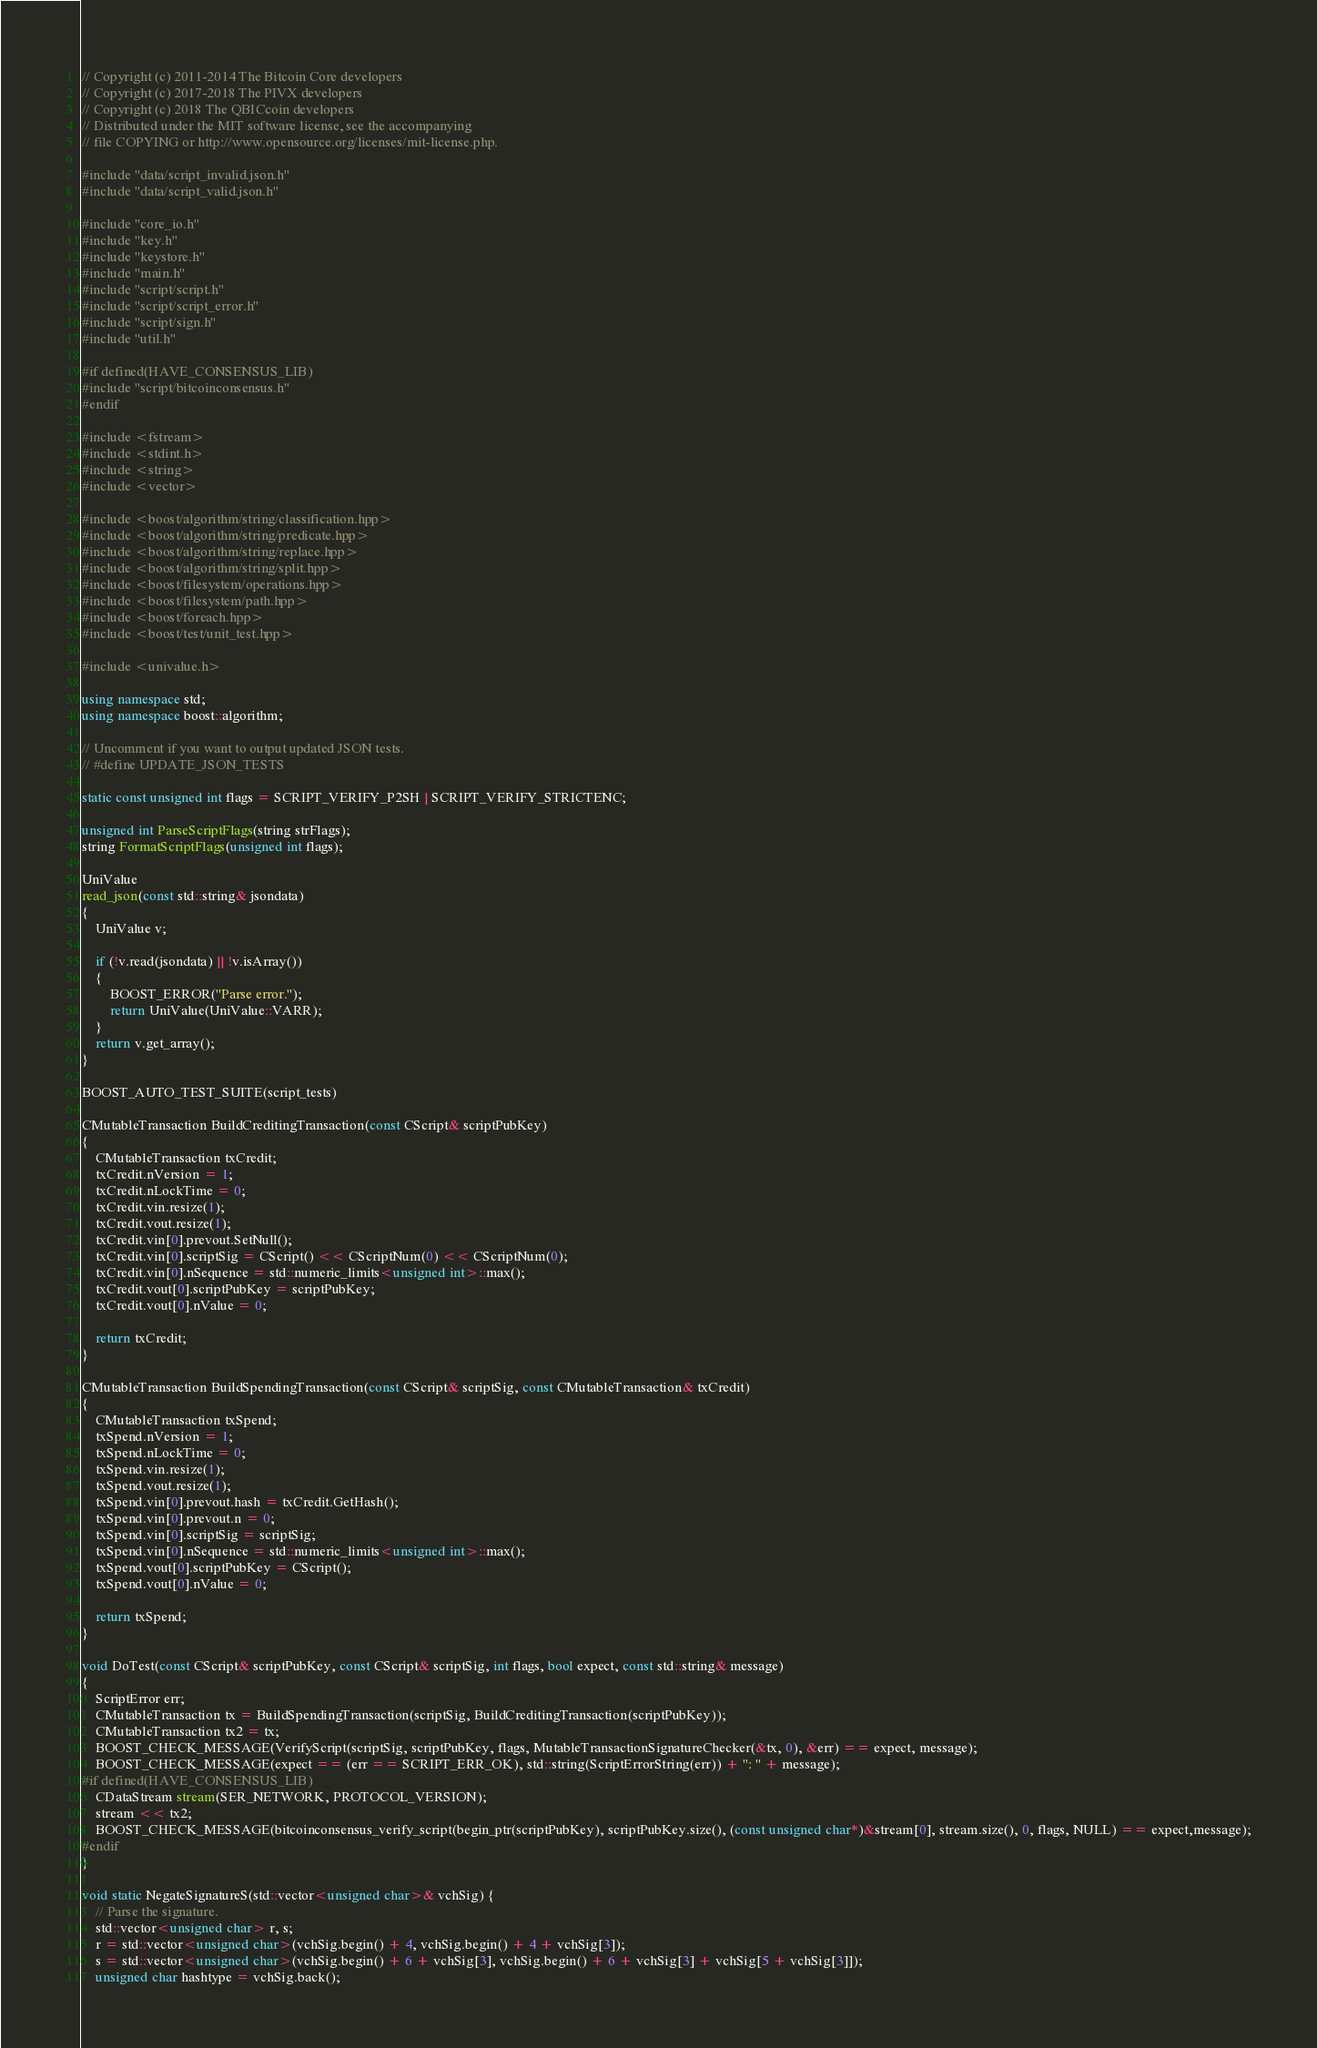Convert code to text. <code><loc_0><loc_0><loc_500><loc_500><_C++_>// Copyright (c) 2011-2014 The Bitcoin Core developers
// Copyright (c) 2017-2018 The PIVX developers
// Copyright (c) 2018 The QBICcoin developers
// Distributed under the MIT software license, see the accompanying
// file COPYING or http://www.opensource.org/licenses/mit-license.php.

#include "data/script_invalid.json.h"
#include "data/script_valid.json.h"

#include "core_io.h"
#include "key.h"
#include "keystore.h"
#include "main.h"
#include "script/script.h"
#include "script/script_error.h"
#include "script/sign.h"
#include "util.h"

#if defined(HAVE_CONSENSUS_LIB)
#include "script/bitcoinconsensus.h"
#endif

#include <fstream>
#include <stdint.h>
#include <string>
#include <vector>

#include <boost/algorithm/string/classification.hpp>
#include <boost/algorithm/string/predicate.hpp>
#include <boost/algorithm/string/replace.hpp>
#include <boost/algorithm/string/split.hpp>
#include <boost/filesystem/operations.hpp>
#include <boost/filesystem/path.hpp>
#include <boost/foreach.hpp>
#include <boost/test/unit_test.hpp>

#include <univalue.h>

using namespace std;
using namespace boost::algorithm;

// Uncomment if you want to output updated JSON tests.
// #define UPDATE_JSON_TESTS

static const unsigned int flags = SCRIPT_VERIFY_P2SH | SCRIPT_VERIFY_STRICTENC;

unsigned int ParseScriptFlags(string strFlags);
string FormatScriptFlags(unsigned int flags);

UniValue
read_json(const std::string& jsondata)
{
    UniValue v;

    if (!v.read(jsondata) || !v.isArray())
    {
        BOOST_ERROR("Parse error.");
        return UniValue(UniValue::VARR);
    }
    return v.get_array();
}

BOOST_AUTO_TEST_SUITE(script_tests)

CMutableTransaction BuildCreditingTransaction(const CScript& scriptPubKey)
{
    CMutableTransaction txCredit;
    txCredit.nVersion = 1;
    txCredit.nLockTime = 0;
    txCredit.vin.resize(1);
    txCredit.vout.resize(1);
    txCredit.vin[0].prevout.SetNull();
    txCredit.vin[0].scriptSig = CScript() << CScriptNum(0) << CScriptNum(0);
    txCredit.vin[0].nSequence = std::numeric_limits<unsigned int>::max();
    txCredit.vout[0].scriptPubKey = scriptPubKey;
    txCredit.vout[0].nValue = 0;

    return txCredit;
}

CMutableTransaction BuildSpendingTransaction(const CScript& scriptSig, const CMutableTransaction& txCredit)
{
    CMutableTransaction txSpend;
    txSpend.nVersion = 1;
    txSpend.nLockTime = 0;
    txSpend.vin.resize(1);
    txSpend.vout.resize(1);
    txSpend.vin[0].prevout.hash = txCredit.GetHash();
    txSpend.vin[0].prevout.n = 0;
    txSpend.vin[0].scriptSig = scriptSig;
    txSpend.vin[0].nSequence = std::numeric_limits<unsigned int>::max();
    txSpend.vout[0].scriptPubKey = CScript();
    txSpend.vout[0].nValue = 0;

    return txSpend;
}

void DoTest(const CScript& scriptPubKey, const CScript& scriptSig, int flags, bool expect, const std::string& message)
{
    ScriptError err;
    CMutableTransaction tx = BuildSpendingTransaction(scriptSig, BuildCreditingTransaction(scriptPubKey));
    CMutableTransaction tx2 = tx;
    BOOST_CHECK_MESSAGE(VerifyScript(scriptSig, scriptPubKey, flags, MutableTransactionSignatureChecker(&tx, 0), &err) == expect, message);
    BOOST_CHECK_MESSAGE(expect == (err == SCRIPT_ERR_OK), std::string(ScriptErrorString(err)) + ": " + message);
#if defined(HAVE_CONSENSUS_LIB)
    CDataStream stream(SER_NETWORK, PROTOCOL_VERSION);
    stream << tx2;
    BOOST_CHECK_MESSAGE(bitcoinconsensus_verify_script(begin_ptr(scriptPubKey), scriptPubKey.size(), (const unsigned char*)&stream[0], stream.size(), 0, flags, NULL) == expect,message);
#endif
}

void static NegateSignatureS(std::vector<unsigned char>& vchSig) {
    // Parse the signature.
    std::vector<unsigned char> r, s;
    r = std::vector<unsigned char>(vchSig.begin() + 4, vchSig.begin() + 4 + vchSig[3]);
    s = std::vector<unsigned char>(vchSig.begin() + 6 + vchSig[3], vchSig.begin() + 6 + vchSig[3] + vchSig[5 + vchSig[3]]);
    unsigned char hashtype = vchSig.back();
</code> 